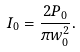Convert formula to latex. <formula><loc_0><loc_0><loc_500><loc_500>I _ { 0 } = { \frac { 2 P _ { 0 } } { \pi w _ { 0 } ^ { 2 } } } .</formula> 